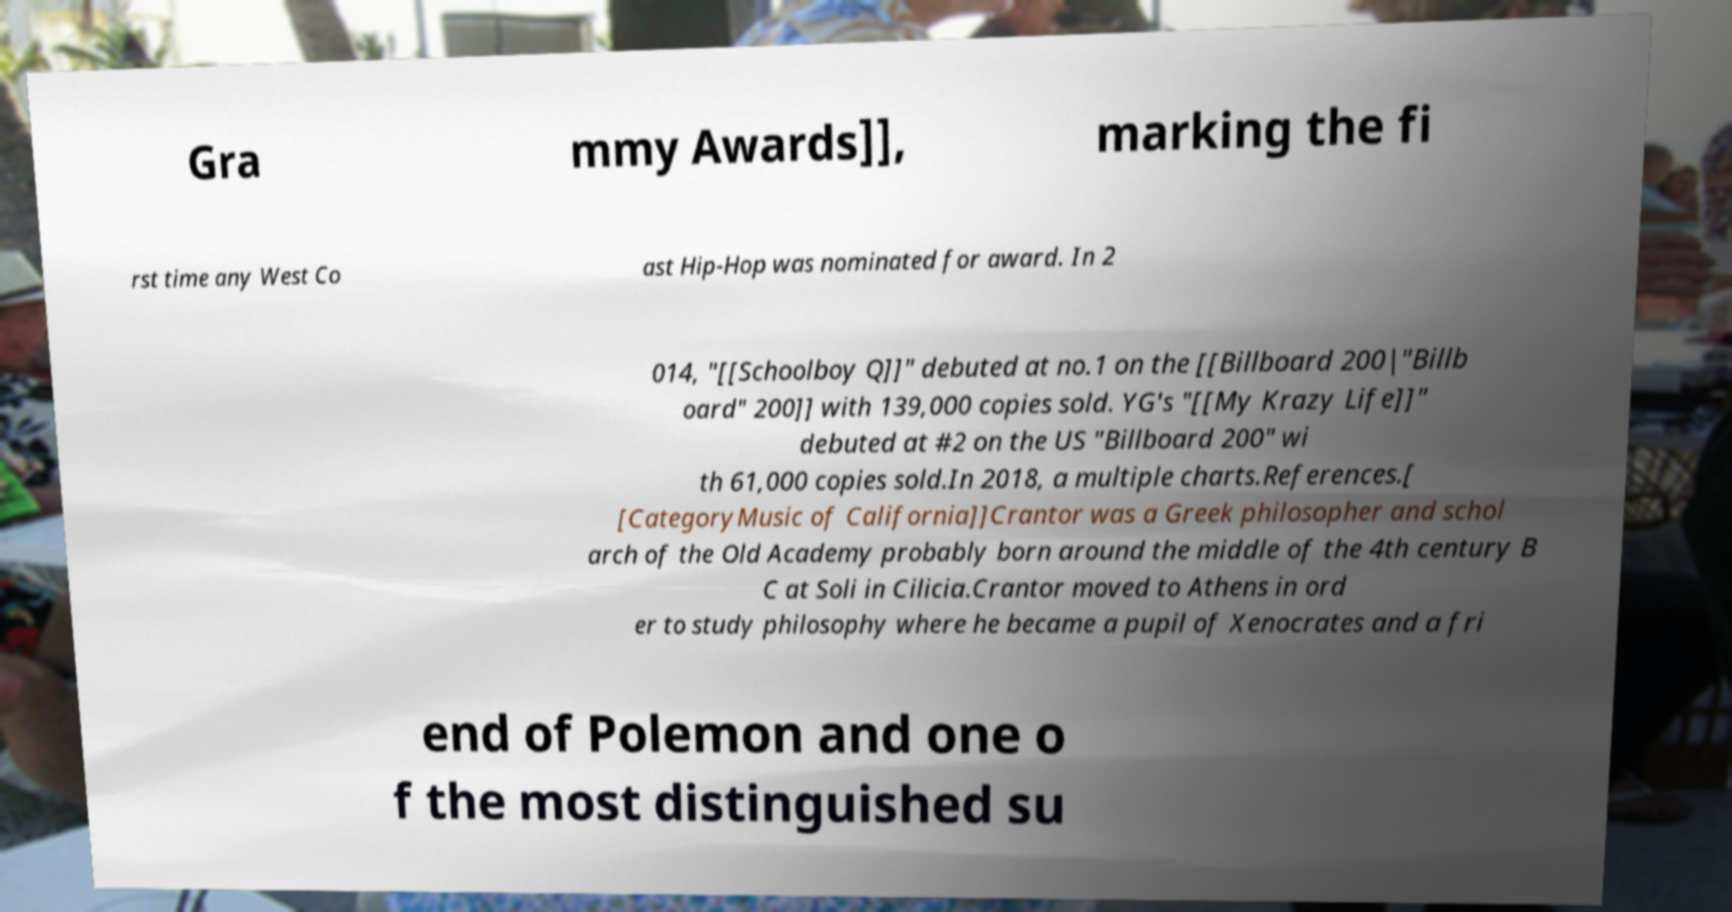Can you read and provide the text displayed in the image?This photo seems to have some interesting text. Can you extract and type it out for me? Gra mmy Awards]], marking the fi rst time any West Co ast Hip-Hop was nominated for award. In 2 014, "[[Schoolboy Q]]" debuted at no.1 on the [[Billboard 200|"Billb oard" 200]] with 139,000 copies sold. YG's "[[My Krazy Life]]" debuted at #2 on the US "Billboard 200" wi th 61,000 copies sold.In 2018, a multiple charts.References.[ [CategoryMusic of California]]Crantor was a Greek philosopher and schol arch of the Old Academy probably born around the middle of the 4th century B C at Soli in Cilicia.Crantor moved to Athens in ord er to study philosophy where he became a pupil of Xenocrates and a fri end of Polemon and one o f the most distinguished su 